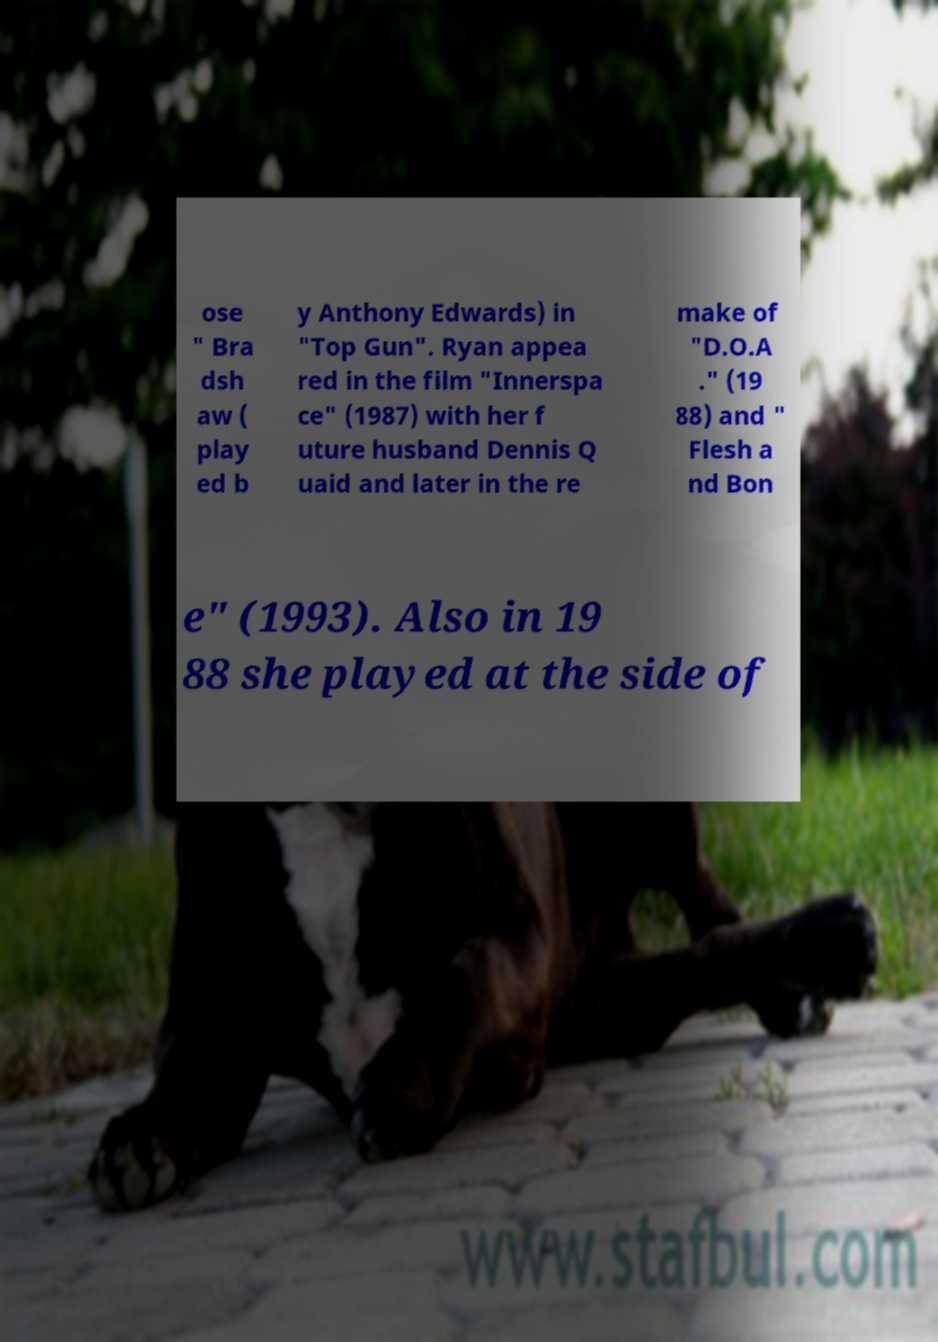I need the written content from this picture converted into text. Can you do that? ose " Bra dsh aw ( play ed b y Anthony Edwards) in "Top Gun". Ryan appea red in the film "Innerspa ce" (1987) with her f uture husband Dennis Q uaid and later in the re make of "D.O.A ." (19 88) and " Flesh a nd Bon e" (1993). Also in 19 88 she played at the side of 